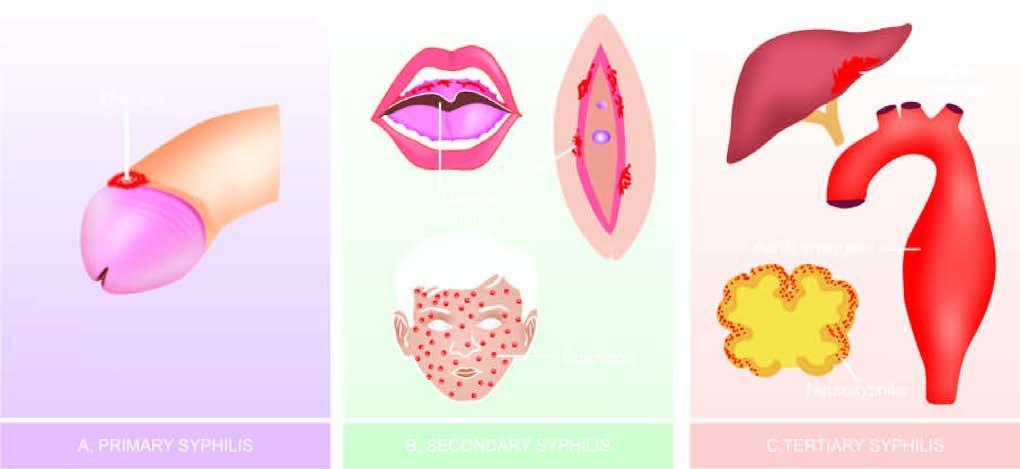s the periphery 'chancre ' on glans penis?
Answer the question using a single word or phrase. No 